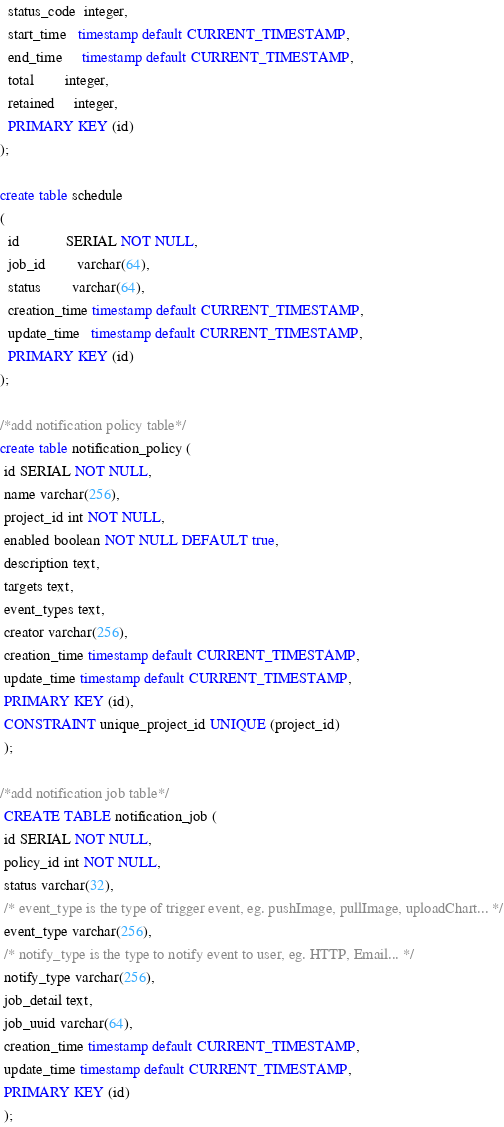Convert code to text. <code><loc_0><loc_0><loc_500><loc_500><_SQL_>  status_code  integer,
  start_time   timestamp default CURRENT_TIMESTAMP,
  end_time     timestamp default CURRENT_TIMESTAMP,
  total        integer,
  retained     integer,
  PRIMARY KEY (id)
);

create table schedule
(
  id            SERIAL NOT NULL,
  job_id        varchar(64),
  status        varchar(64),
  creation_time timestamp default CURRENT_TIMESTAMP,
  update_time   timestamp default CURRENT_TIMESTAMP,
  PRIMARY KEY (id)
);

/*add notification policy table*/
create table notification_policy (
 id SERIAL NOT NULL,
 name varchar(256),
 project_id int NOT NULL,
 enabled boolean NOT NULL DEFAULT true,
 description text,
 targets text,
 event_types text,
 creator varchar(256),
 creation_time timestamp default CURRENT_TIMESTAMP,
 update_time timestamp default CURRENT_TIMESTAMP,
 PRIMARY KEY (id),
 CONSTRAINT unique_project_id UNIQUE (project_id)
 );

/*add notification job table*/
 CREATE TABLE notification_job (
 id SERIAL NOT NULL,
 policy_id int NOT NULL,
 status varchar(32),
 /* event_type is the type of trigger event, eg. pushImage, pullImage, uploadChart... */
 event_type varchar(256),
 /* notify_type is the type to notify event to user, eg. HTTP, Email... */
 notify_type varchar(256),
 job_detail text,
 job_uuid varchar(64),
 creation_time timestamp default CURRENT_TIMESTAMP,
 update_time timestamp default CURRENT_TIMESTAMP,
 PRIMARY KEY (id)
 );
</code> 